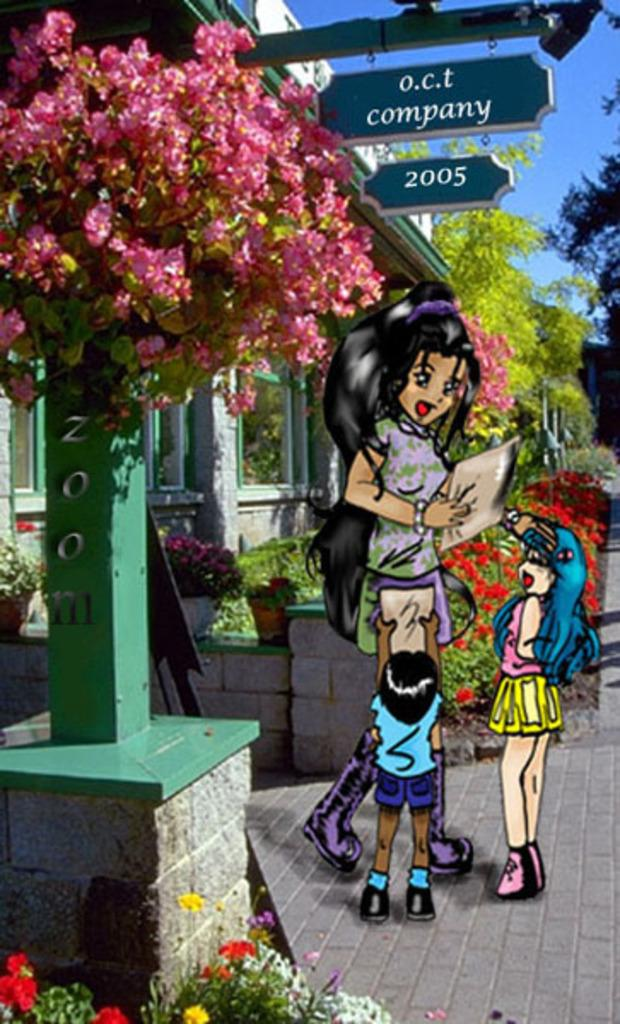What type of picture is in the image? The image contains an edited picture. What can be seen on the floor in the image? There are cartoons standing on the floor. What type of vegetation is present in the image? There are flowers, shrubs, trees, and creepers in the image. What type of structure is visible in the image? There is a building in the image. What type of signage is present in the image? There are name boards in the image. What part of the natural environment is visible in the image? The sky is visible in the image. What type of calculator is visible in the image? There is no calculator present in the image. What type of ship can be seen sailing in the image? There is no ship present in the image. 